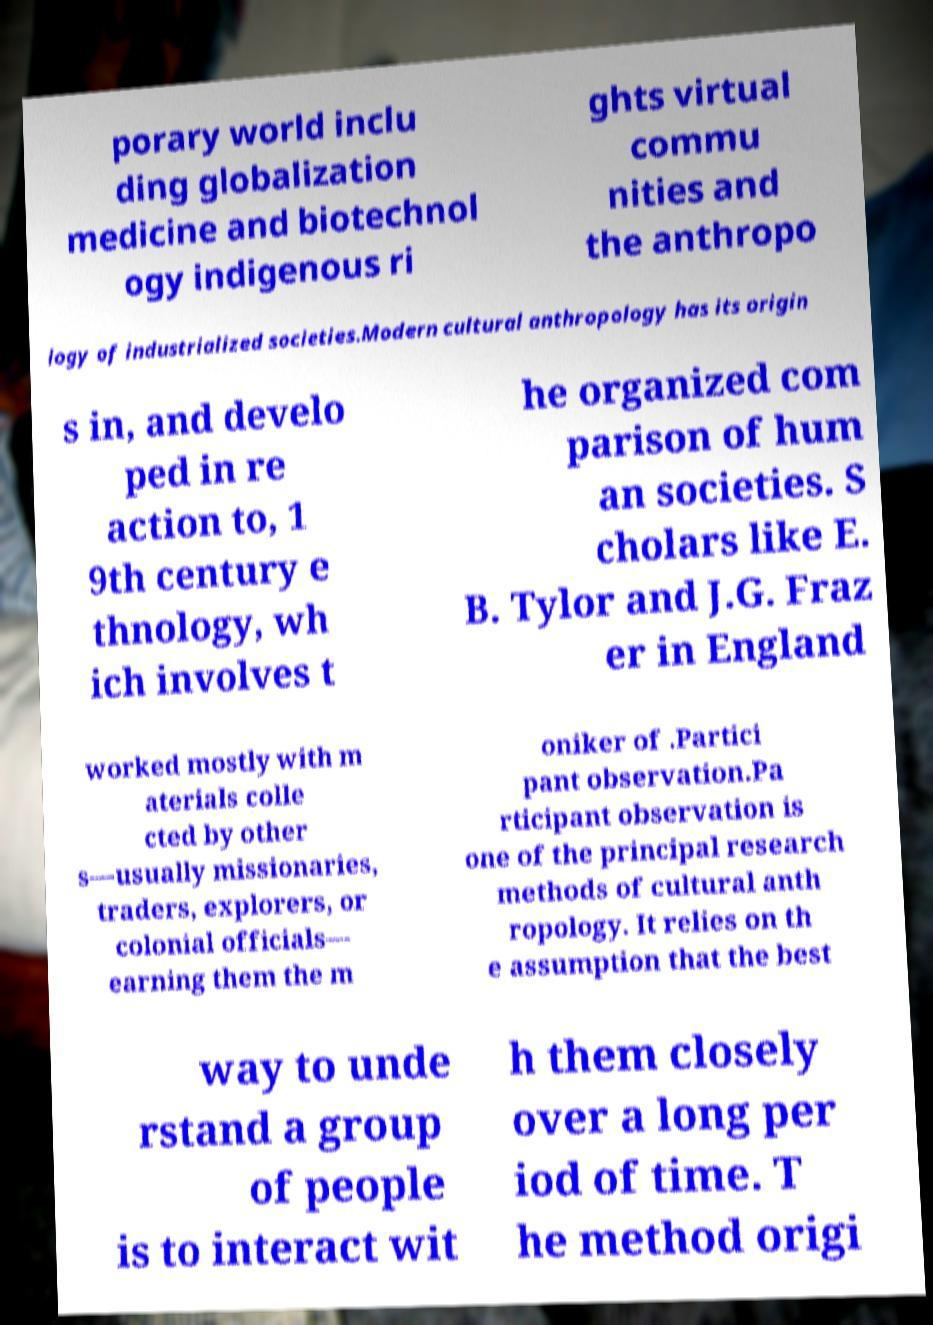Can you accurately transcribe the text from the provided image for me? porary world inclu ding globalization medicine and biotechnol ogy indigenous ri ghts virtual commu nities and the anthropo logy of industrialized societies.Modern cultural anthropology has its origin s in, and develo ped in re action to, 1 9th century e thnology, wh ich involves t he organized com parison of hum an societies. S cholars like E. B. Tylor and J.G. Fraz er in England worked mostly with m aterials colle cted by other s—usually missionaries, traders, explorers, or colonial officials— earning them the m oniker of .Partici pant observation.Pa rticipant observation is one of the principal research methods of cultural anth ropology. It relies on th e assumption that the best way to unde rstand a group of people is to interact wit h them closely over a long per iod of time. T he method origi 